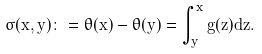Convert formula to latex. <formula><loc_0><loc_0><loc_500><loc_500>\sigma ( x , y ) \colon = \theta ( x ) - \theta ( y ) = \int ^ { x } _ { y } g ( z ) d z .</formula> 